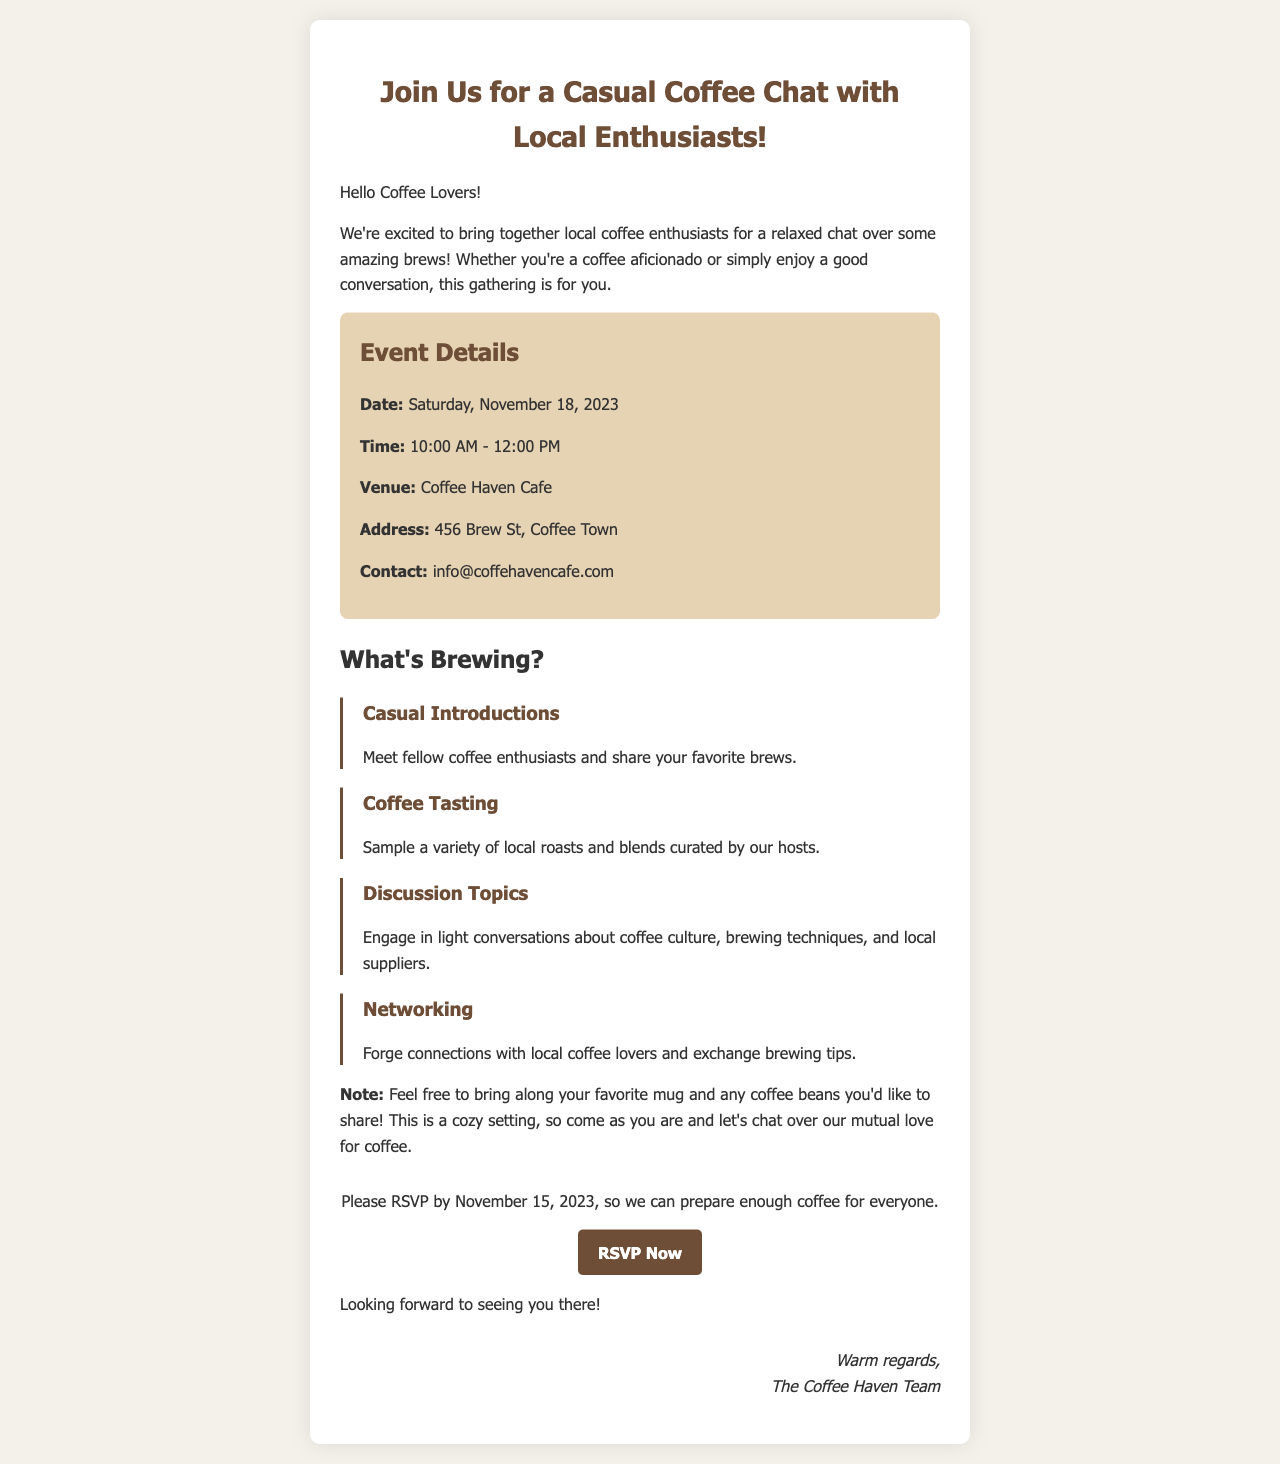What is the date of the event? The event is scheduled for Saturday, November 18, 2023, as mentioned in the event details.
Answer: Saturday, November 18, 2023 What time does the gathering start? The gathering starts at 10:00 AM, which is specified in the event details section.
Answer: 10:00 AM Where is the venue located? The venue is Coffee Haven Cafe, located at 456 Brew St, Coffee Town, as stated in the document.
Answer: Coffee Haven Cafe What should attendees bring? Attendees are encouraged to bring their favorite mug and any coffee beans they'd like to share, as noted in the document.
Answer: Favorite mug and coffee beans By when do you need to RSVP? The RSVP deadline is November 15, 2023, indicated in the call-to-action section of the document.
Answer: November 15, 2023 What is included in the agenda item about coffee? The agenda item mentions a coffee tasting where a variety of local roasts and blends will be sampled.
Answer: Coffee tasting Who is hosting the event? The event is organized by The Coffee Haven Team, as mentioned in the signature at the end of the document.
Answer: The Coffee Haven Team What is the main purpose of the event? The main purpose is to bring together local coffee enthusiasts for a relaxed chat over coffee, as described at the beginning of the document.
Answer: Casual chat over coffee 